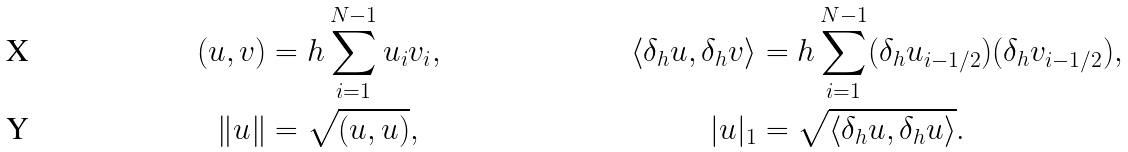Convert formula to latex. <formula><loc_0><loc_0><loc_500><loc_500>( u , v ) & = h \sum _ { i = 1 } ^ { N - 1 } u _ { i } v _ { i } , & \langle \delta _ { h } u , \delta _ { h } v \rangle & = h \sum _ { i = 1 } ^ { N - 1 } ( \delta _ { h } u _ { i - 1 / 2 } ) ( \delta _ { h } v _ { i - 1 / 2 } ) , \\ \| u \| & = \sqrt { ( u , u ) } , & | u | _ { 1 } & = \sqrt { \langle \delta _ { h } u , \delta _ { h } u \rangle } .</formula> 